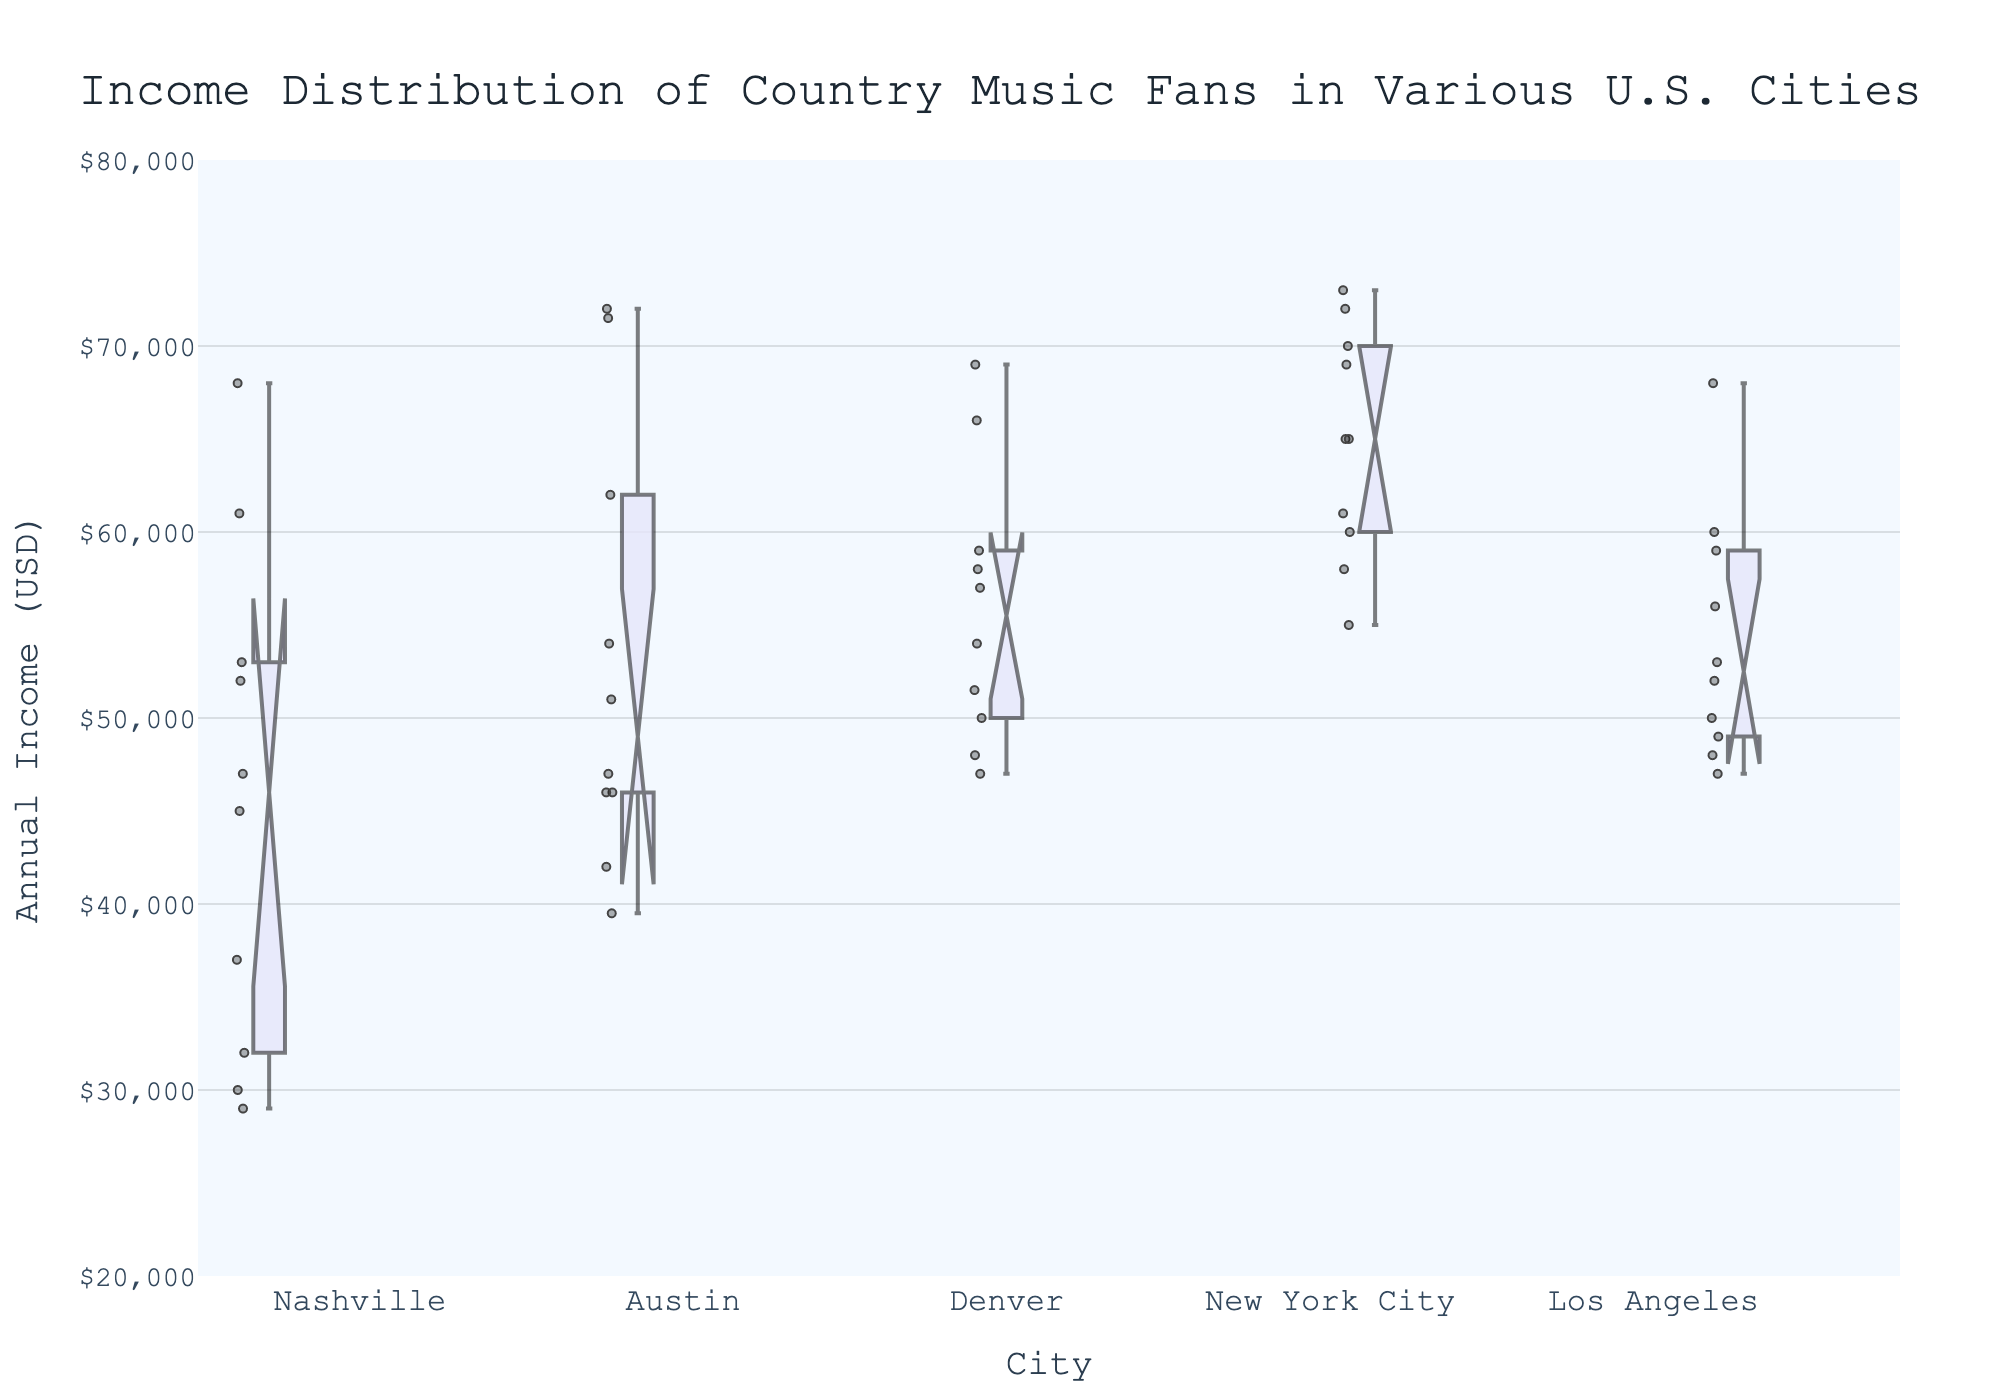What is the title of the box plot? The title of the box plot is displayed at the top center of the figure, indicating what the plot is about.
Answer: Income Distribution of Country Music Fans in Various U.S. Cities What does the y-axis represent? The y-axis label describes what the vertical axis measures. In this case, it specifies the measurement unit and subject.
Answer: Annual Income (USD) Which city has the highest median income? To find the highest median income, look at the horizontal line inside each box. Compare these lines across all cities. New York City has the highest median income because its median line is higher than all other cities'.
Answer: New York City What is the interquartile range (IQR) for Austin? Identify the lower and upper quartiles of the box for Austin. The IQR is the difference between these two points: ($54000 - $46000 = $8000).
Answer: $8000 Does any city have outliers plotted outside the whiskers? Outliers are data points that are displayed outside the whiskers of the box plot. Check for any such points in each city's box plot. Yes, there are some outliers, for example, in Austin and Denver.
Answer: Yes Which city has the lowest spread in income distribution, and how can you tell? The spread can be assessed by the length of the box and whiskers of each city. The city with the shortest overall length has the least spread. Nashville has the shortest overall box and whiskers.
Answer: Nashville How does the income distribution for Los Angeles compare to that of Denver? Compare the median, interquartile range, and the position of whiskers to see differences. Denver has a slightly higher median and a wider IQR than Los Angeles.
Answer: Denver has a slightly higher median and wider IQR than Los Angeles What is the approximate range of incomes for New York City? The range is determined by the smallest and largest values within the whiskers. Approximate the values at the ends of the whiskers for New York City: (~$55000 to ~$73000).
Answer: ~$55000 to ~$73000 Are there any overlaps in income distributions among the cities? Look for notches in the boxes. If notches in the boxes for different cities overlap, their medians are not significantly different. For example, the notches of some cities like Denver and New York City overlap.
Answer: Yes 